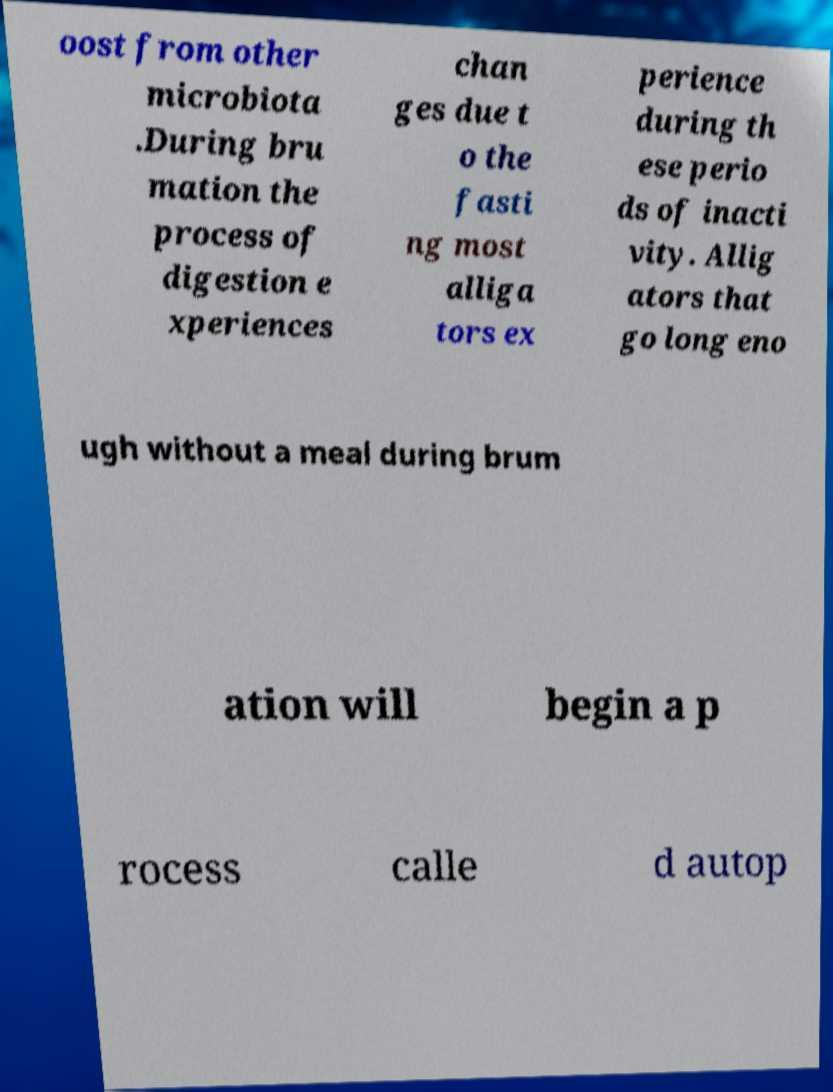Can you read and provide the text displayed in the image?This photo seems to have some interesting text. Can you extract and type it out for me? oost from other microbiota .During bru mation the process of digestion e xperiences chan ges due t o the fasti ng most alliga tors ex perience during th ese perio ds of inacti vity. Allig ators that go long eno ugh without a meal during brum ation will begin a p rocess calle d autop 